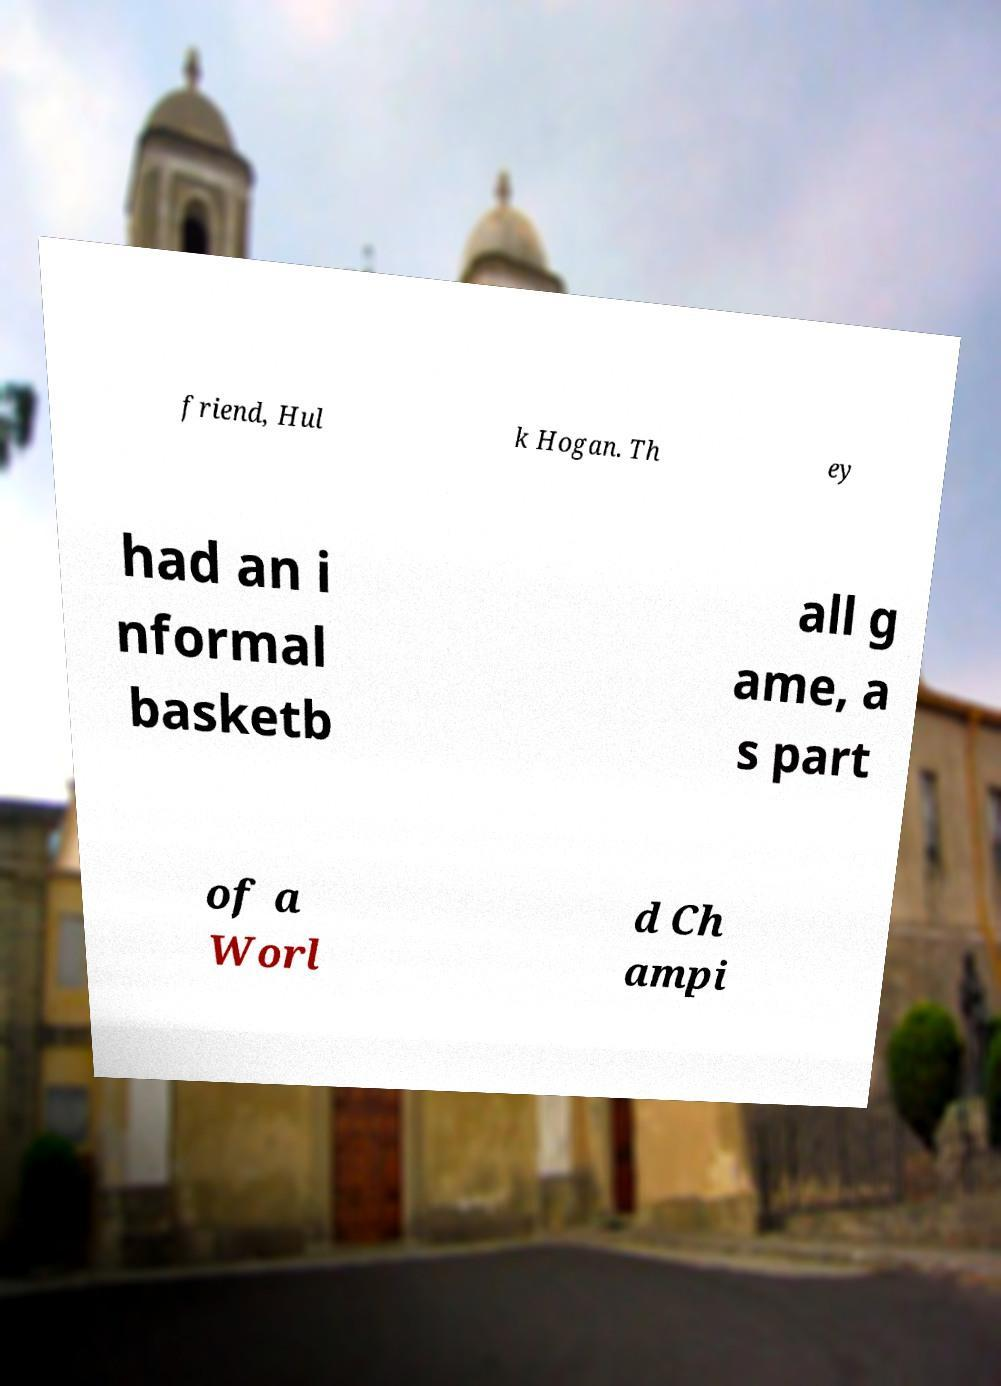For documentation purposes, I need the text within this image transcribed. Could you provide that? friend, Hul k Hogan. Th ey had an i nformal basketb all g ame, a s part of a Worl d Ch ampi 